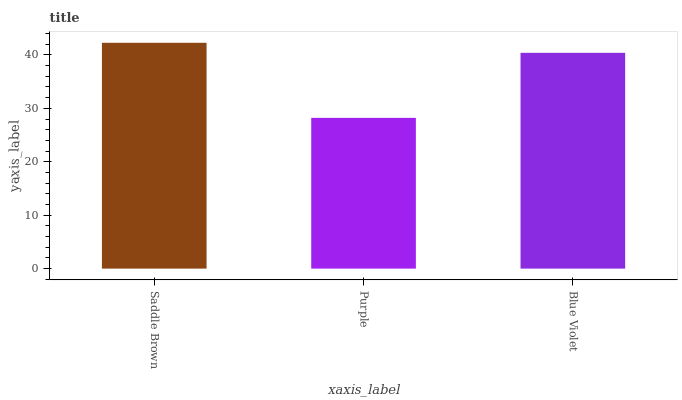Is Purple the minimum?
Answer yes or no. Yes. Is Saddle Brown the maximum?
Answer yes or no. Yes. Is Blue Violet the minimum?
Answer yes or no. No. Is Blue Violet the maximum?
Answer yes or no. No. Is Blue Violet greater than Purple?
Answer yes or no. Yes. Is Purple less than Blue Violet?
Answer yes or no. Yes. Is Purple greater than Blue Violet?
Answer yes or no. No. Is Blue Violet less than Purple?
Answer yes or no. No. Is Blue Violet the high median?
Answer yes or no. Yes. Is Blue Violet the low median?
Answer yes or no. Yes. Is Saddle Brown the high median?
Answer yes or no. No. Is Saddle Brown the low median?
Answer yes or no. No. 